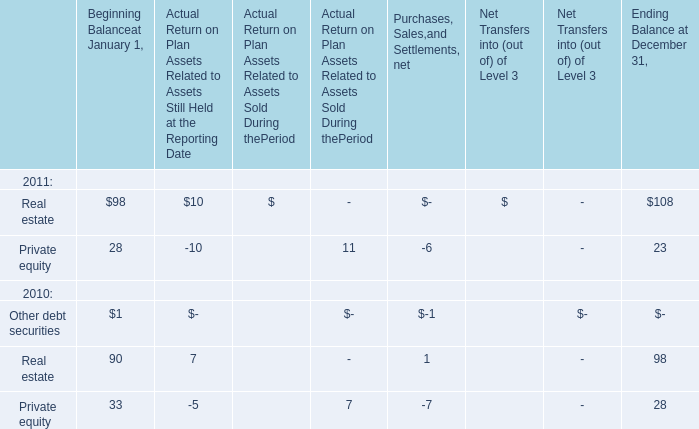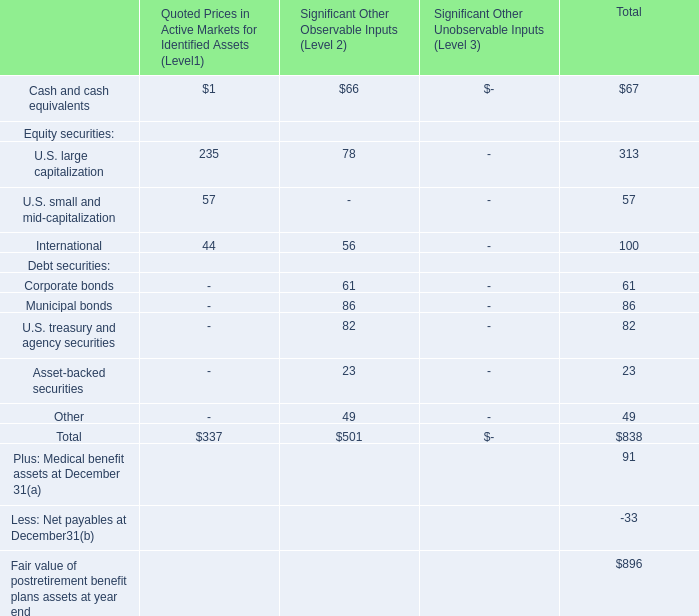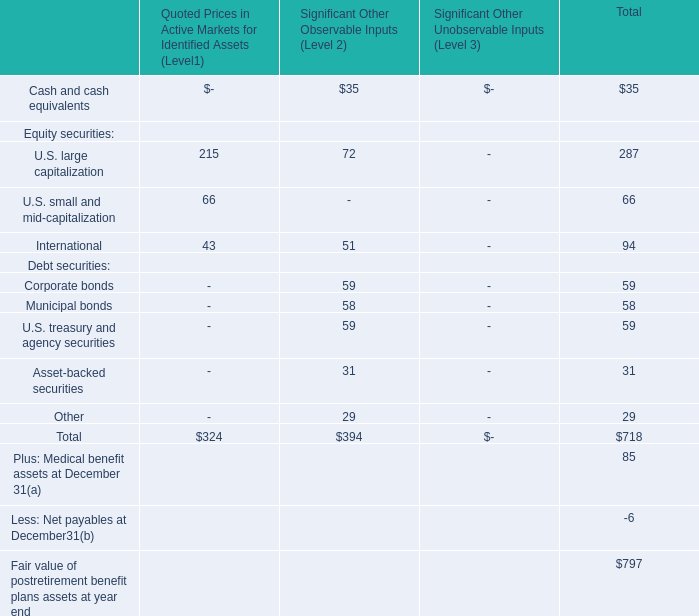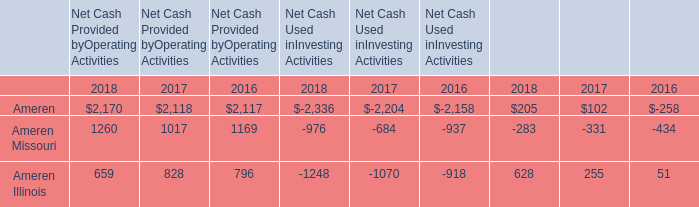How many Beginning Balance at January 1 are greater than 20 in 2011? 
Answer: 2. 